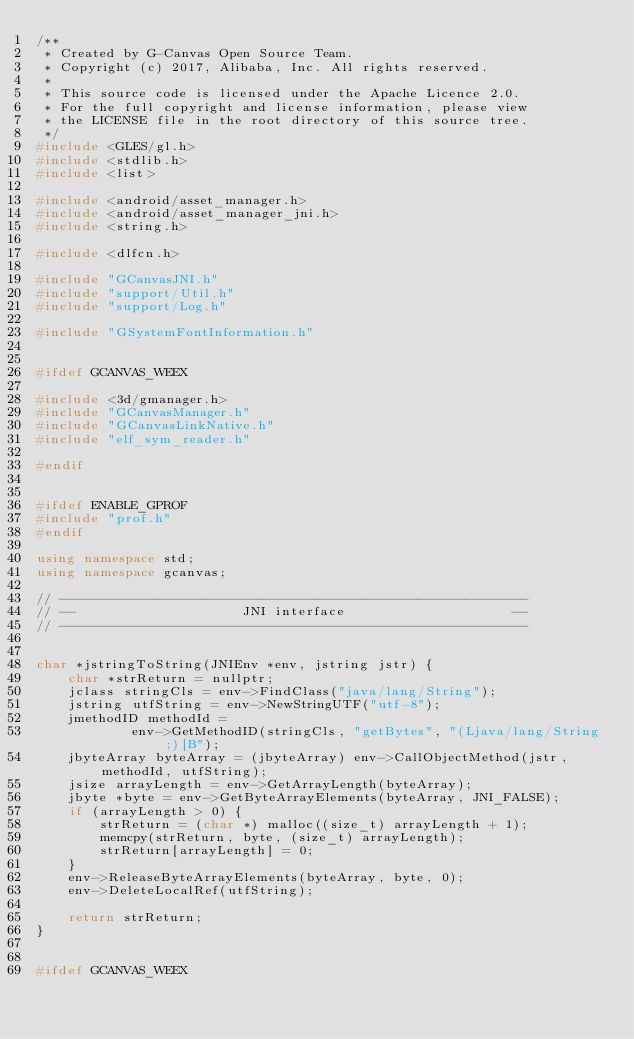<code> <loc_0><loc_0><loc_500><loc_500><_C++_>/**
 * Created by G-Canvas Open Source Team.
 * Copyright (c) 2017, Alibaba, Inc. All rights reserved.
 *
 * This source code is licensed under the Apache Licence 2.0.
 * For the full copyright and license information, please view
 * the LICENSE file in the root directory of this source tree.
 */
#include <GLES/gl.h>
#include <stdlib.h>
#include <list>

#include <android/asset_manager.h>
#include <android/asset_manager_jni.h>
#include <string.h>

#include <dlfcn.h>

#include "GCanvasJNI.h"
#include "support/Util.h"
#include "support/Log.h"

#include "GSystemFontInformation.h"


#ifdef GCANVAS_WEEX

#include <3d/gmanager.h>
#include "GCanvasManager.h"
#include "GCanvasLinkNative.h"
#include "elf_sym_reader.h"

#endif


#ifdef ENABLE_GPROF
#include "prof.h"
#endif

using namespace std;
using namespace gcanvas;

// -----------------------------------------------------------
// --                     JNI interface                     --
// -----------------------------------------------------------


char *jstringToString(JNIEnv *env, jstring jstr) {
    char *strReturn = nullptr;
    jclass stringCls = env->FindClass("java/lang/String");
    jstring utfString = env->NewStringUTF("utf-8");
    jmethodID methodId =
            env->GetMethodID(stringCls, "getBytes", "(Ljava/lang/String;)[B");
    jbyteArray byteArray = (jbyteArray) env->CallObjectMethod(jstr, methodId, utfString);
    jsize arrayLength = env->GetArrayLength(byteArray);
    jbyte *byte = env->GetByteArrayElements(byteArray, JNI_FALSE);
    if (arrayLength > 0) {
        strReturn = (char *) malloc((size_t) arrayLength + 1);
        memcpy(strReturn, byte, (size_t) arrayLength);
        strReturn[arrayLength] = 0;
    }
    env->ReleaseByteArrayElements(byteArray, byte, 0);
    env->DeleteLocalRef(utfString);

    return strReturn;
}


#ifdef GCANVAS_WEEX
</code> 